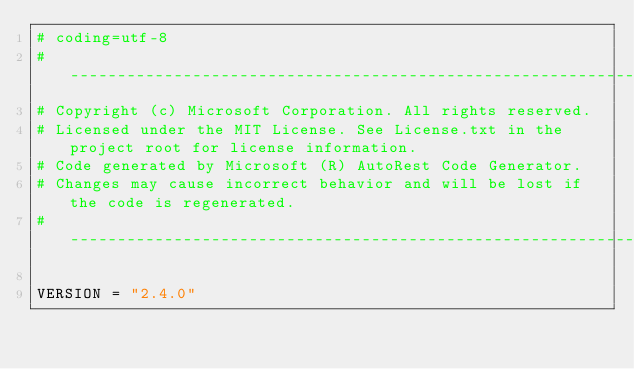Convert code to text. <code><loc_0><loc_0><loc_500><loc_500><_Python_># coding=utf-8
# --------------------------------------------------------------------------
# Copyright (c) Microsoft Corporation. All rights reserved.
# Licensed under the MIT License. See License.txt in the project root for license information.
# Code generated by Microsoft (R) AutoRest Code Generator.
# Changes may cause incorrect behavior and will be lost if the code is regenerated.
# --------------------------------------------------------------------------

VERSION = "2.4.0"
</code> 